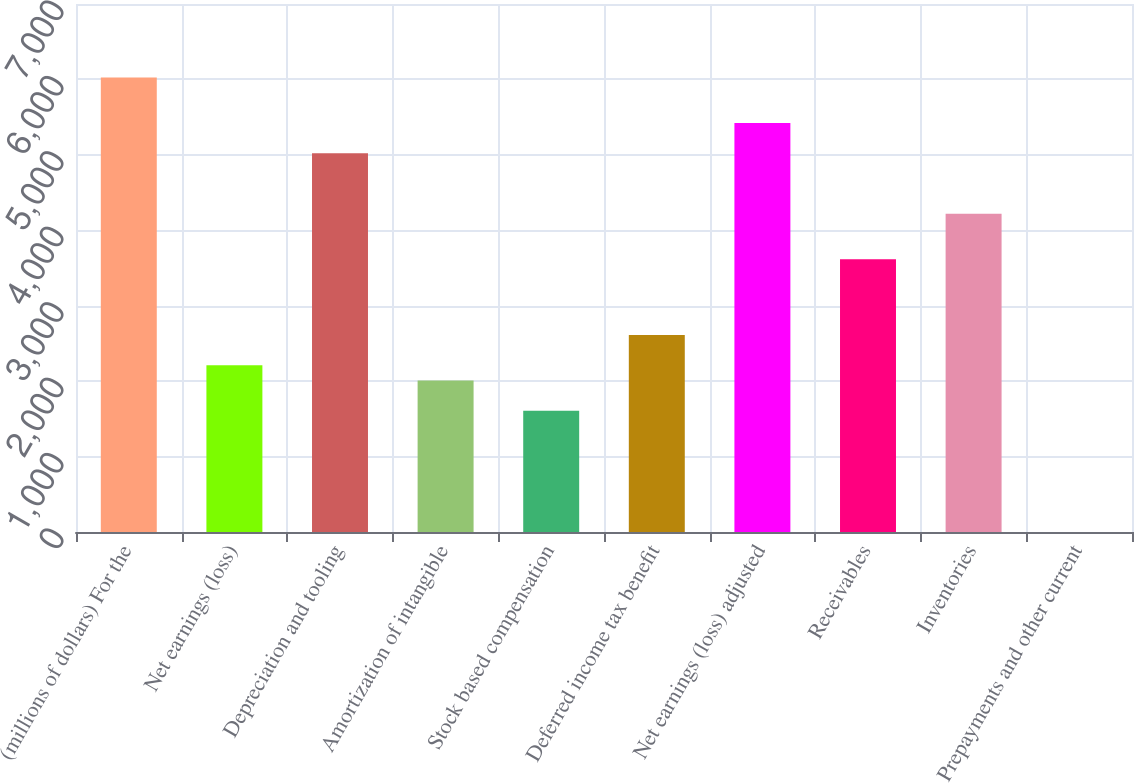Convert chart to OTSL. <chart><loc_0><loc_0><loc_500><loc_500><bar_chart><fcel>(millions of dollars) For the<fcel>Net earnings (loss)<fcel>Depreciation and tooling<fcel>Amortization of intangible<fcel>Stock based compensation<fcel>Deferred income tax benefit<fcel>Net earnings (loss) adjusted<fcel>Receivables<fcel>Inventories<fcel>Prepayments and other current<nl><fcel>6024.6<fcel>2209.78<fcel>5020.7<fcel>2009<fcel>1607.44<fcel>2611.34<fcel>5422.26<fcel>3615.24<fcel>4217.58<fcel>1.2<nl></chart> 